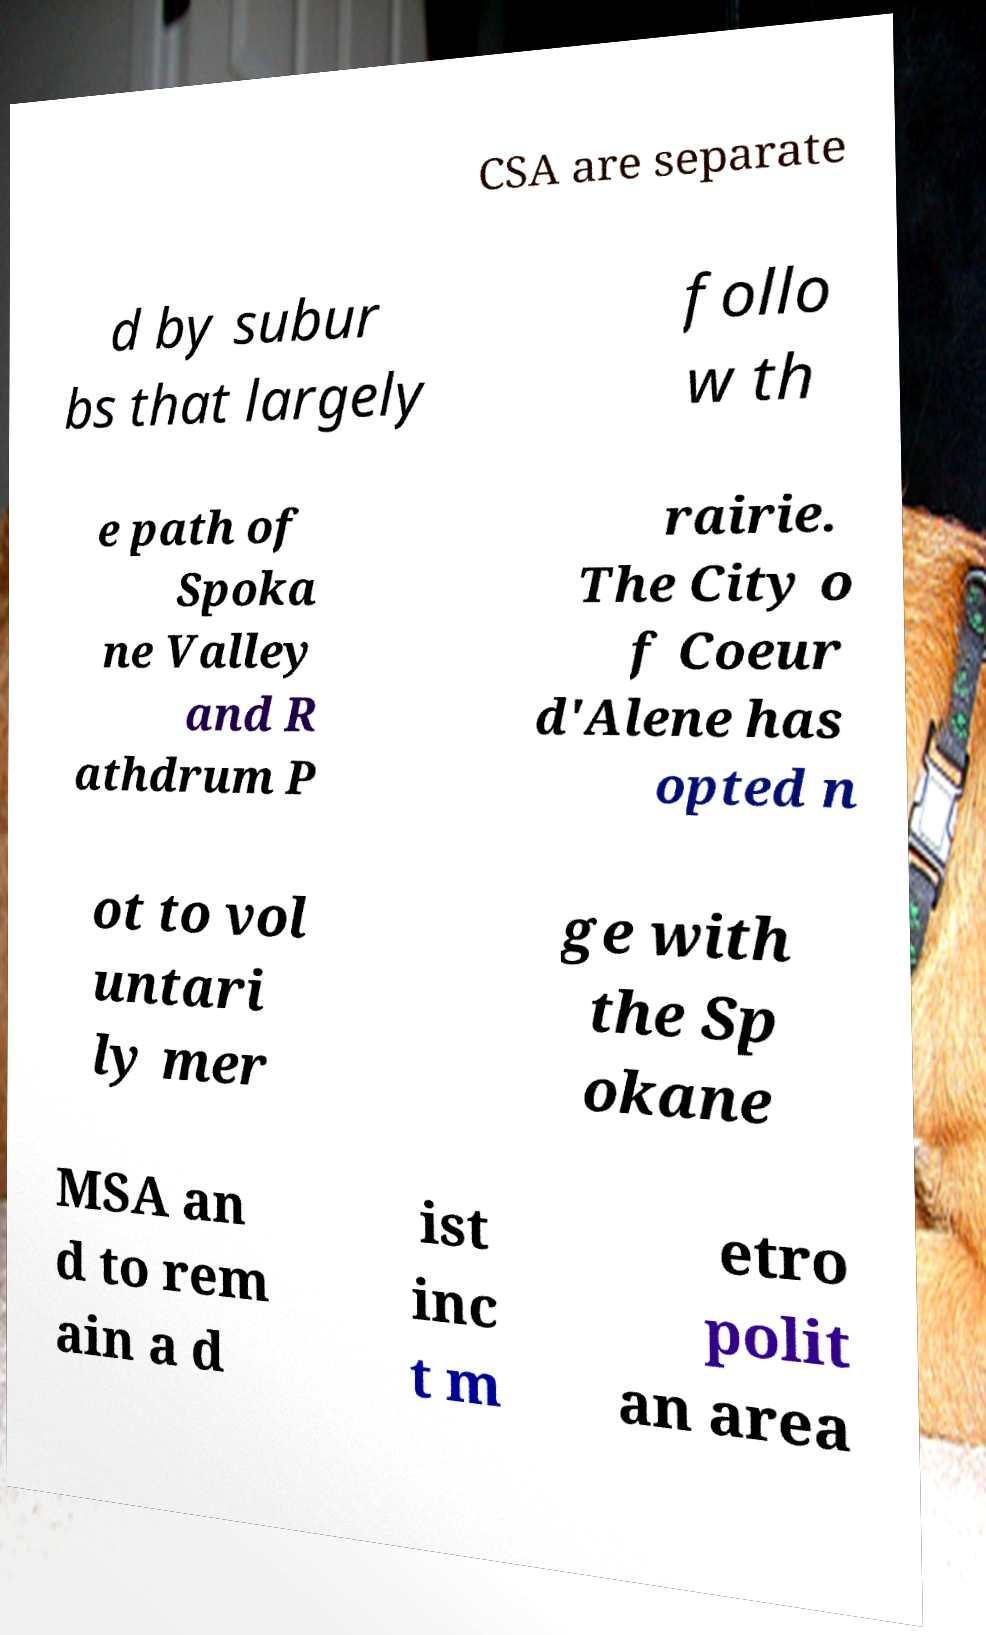What messages or text are displayed in this image? I need them in a readable, typed format. CSA are separate d by subur bs that largely follo w th e path of Spoka ne Valley and R athdrum P rairie. The City o f Coeur d'Alene has opted n ot to vol untari ly mer ge with the Sp okane MSA an d to rem ain a d ist inc t m etro polit an area 